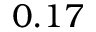<formula> <loc_0><loc_0><loc_500><loc_500>0 . 1 7</formula> 